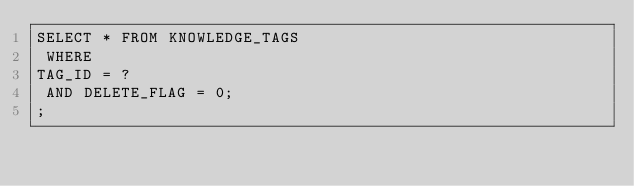<code> <loc_0><loc_0><loc_500><loc_500><_SQL_>SELECT * FROM KNOWLEDGE_TAGS
 WHERE 
TAG_ID = ?
 AND DELETE_FLAG = 0;
;
</code> 